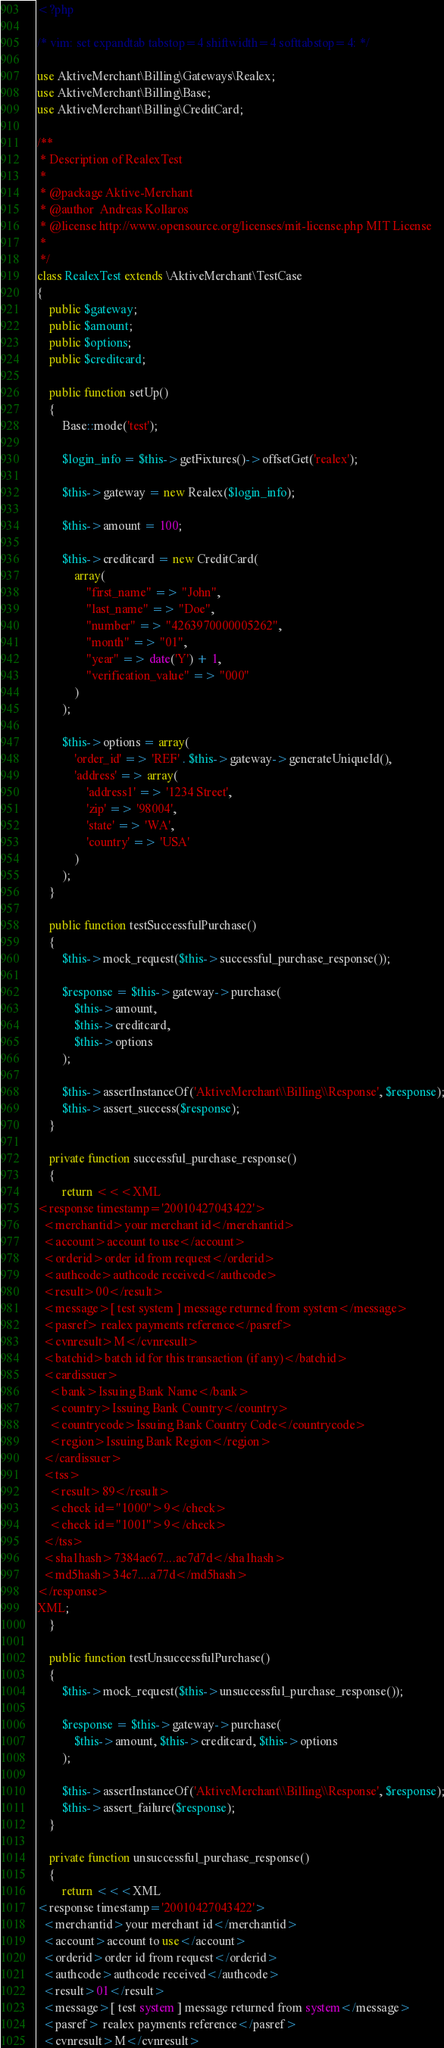<code> <loc_0><loc_0><loc_500><loc_500><_PHP_><?php

/* vim: set expandtab tabstop=4 shiftwidth=4 softtabstop=4: */

use AktiveMerchant\Billing\Gateways\Realex;
use AktiveMerchant\Billing\Base;
use AktiveMerchant\Billing\CreditCard;

/**
 * Description of RealexTest
 *
 * @package Aktive-Merchant
 * @author  Andreas Kollaros
 * @license http://www.opensource.org/licenses/mit-license.php MIT License
 *
 */
class RealexTest extends \AktiveMerchant\TestCase
{
    public $gateway;
    public $amount;
    public $options;
    public $creditcard;

    public function setUp()
    {
        Base::mode('test');

        $login_info = $this->getFixtures()->offsetGet('realex');

        $this->gateway = new Realex($login_info);

        $this->amount = 100;

        $this->creditcard = new CreditCard(
            array(
                "first_name" => "John",
                "last_name" => "Doe",
                "number" => "4263970000005262",
                "month" => "01",
                "year" => date('Y') + 1,
                "verification_value" => "000"
            )
        );

        $this->options = array(
            'order_id' => 'REF' . $this->gateway->generateUniqueId(),
            'address' => array(
                'address1' => '1234 Street',
                'zip' => '98004',
                'state' => 'WA',
                'country' => 'USA'
            )
        );
    }

    public function testSuccessfulPurchase()
    {
        $this->mock_request($this->successful_purchase_response());

        $response = $this->gateway->purchase(
            $this->amount,
            $this->creditcard,
            $this->options
        );

        $this->assertInstanceOf('AktiveMerchant\\Billing\\Response', $response);
        $this->assert_success($response);
    }

    private function successful_purchase_response()
    {
        return <<<XML
<response timestamp='20010427043422'>
  <merchantid>your merchant id</merchantid>
  <account>account to use</account>
  <orderid>order id from request</orderid>
  <authcode>authcode received</authcode>
  <result>00</result>
  <message>[ test system ] message returned from system</message>
  <pasref> realex payments reference</pasref>
  <cvnresult>M</cvnresult>
  <batchid>batch id for this transaction (if any)</batchid>
  <cardissuer>
    <bank>Issuing Bank Name</bank>
    <country>Issuing Bank Country</country>
    <countrycode>Issuing Bank Country Code</countrycode>
    <region>Issuing Bank Region</region>
  </cardissuer>
  <tss>
    <result>89</result>
    <check id="1000">9</check>
    <check id="1001">9</check>
  </tss>
  <sha1hash>7384ae67....ac7d7d</sha1hash>
  <md5hash>34e7....a77d</md5hash>
</response>
XML;
    }

    public function testUnsuccessfulPurchase()
    {
        $this->mock_request($this->unsuccessful_purchase_response());

        $response = $this->gateway->purchase(
            $this->amount, $this->creditcard, $this->options
        );

        $this->assertInstanceOf('AktiveMerchant\\Billing\\Response', $response);
        $this->assert_failure($response);
    }

    private function unsuccessful_purchase_response()
    {
        return <<<XML
<response timestamp='20010427043422'>
  <merchantid>your merchant id</merchantid>
  <account>account to use</account>
  <orderid>order id from request</orderid>
  <authcode>authcode received</authcode>
  <result>01</result>
  <message>[ test system ] message returned from system</message>
  <pasref> realex payments reference</pasref>
  <cvnresult>M</cvnresult></code> 